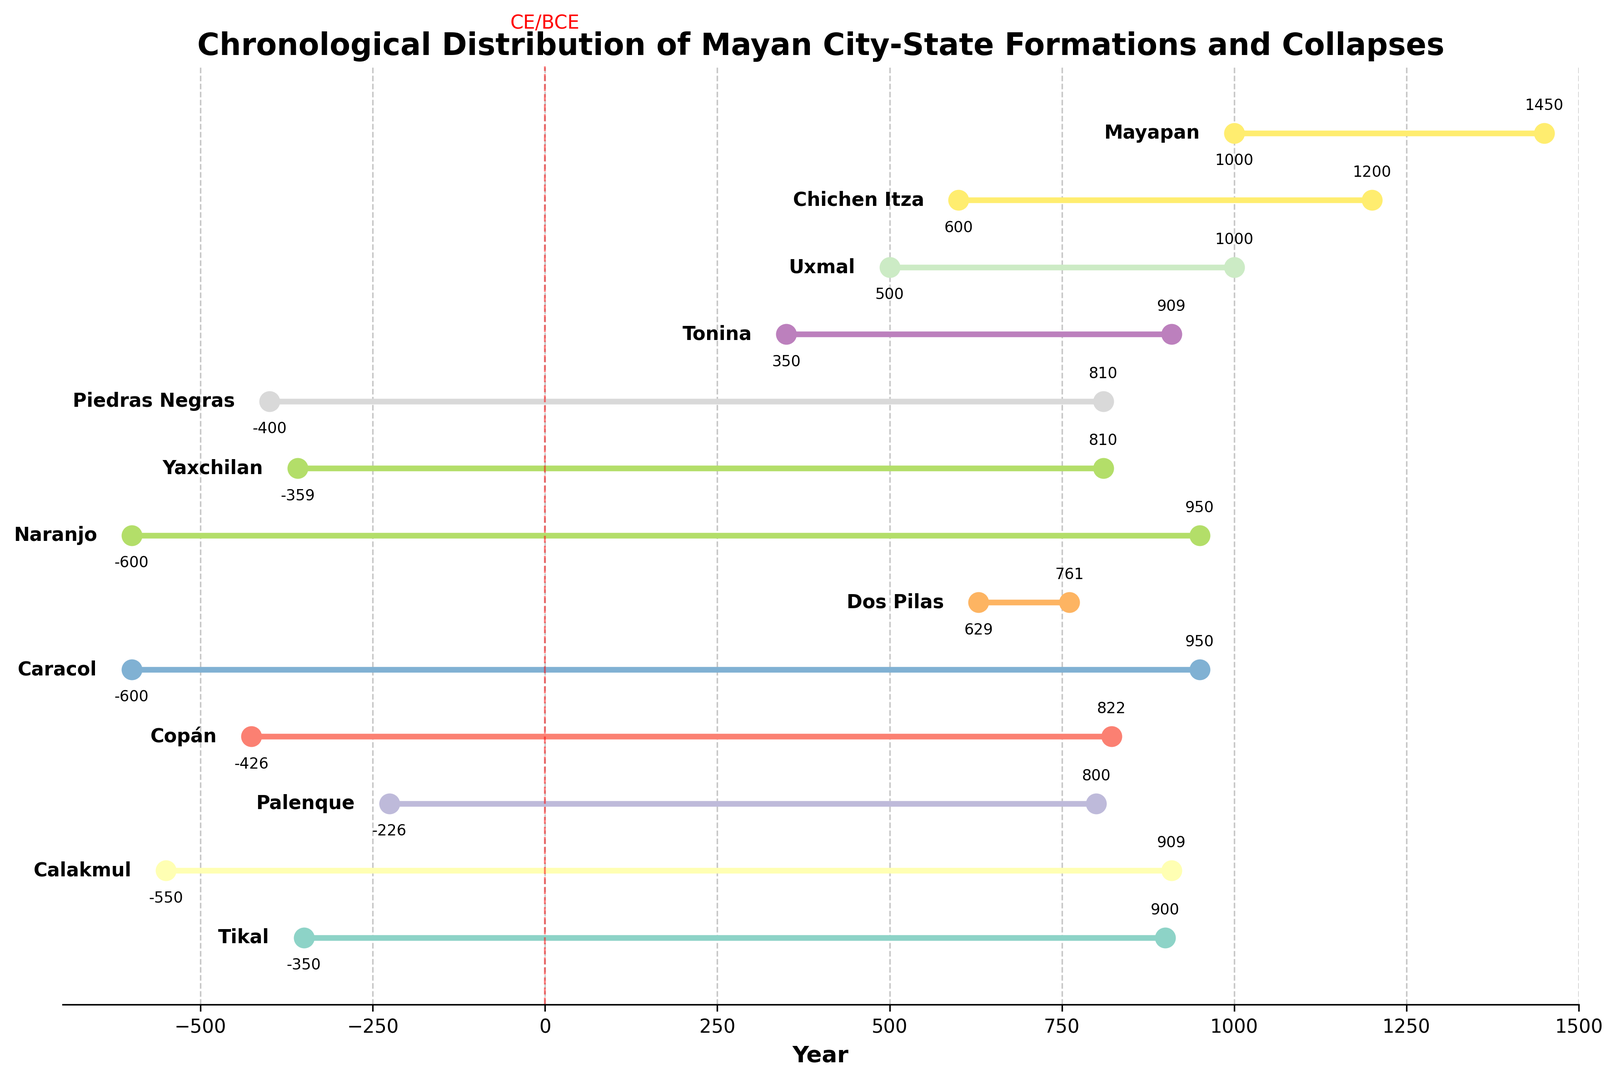Which Mayan city-state formed the earliest? To find the earliest formation, look at the lowest year value under 'Formation' events. The lowest value is -600 for Caracol and Naranjo.
Answer: Caracol and Naranjo Which Mayan city-state collapsed the latest? To find the latest collapse, look at the highest year value under 'Collapse' events. The highest value is 1450 for Mayapan.
Answer: Mayapan How many city-states were formed before the Common Era (BCE)? Identify the formation years that are negative (before CE). The city-states with negative formation years are: Tikal, Calakmul, Palenque, Copán, Caracol, Naranjo, Yaxchilan, and Piedras Negras, making a total of 8 city-states.
Answer: 8 How many years did Tikal exist? Find the difference between the collapse year and the formation year of Tikal. The collapse year is 900 and the formation year is -350. The total duration is 900 - (-350) = 1250 years.
Answer: 1250 years Which city-state had the shortest duration between its formation and collapse? Calculate the duration for each city-state by subtracting the formation year from the collapse year. Identify the smallest duration. Tonina was formed in 350 and collapsed in 909, which gives a duration of 909 - 350 = 559 years.
Answer: Tonina What is the average duration of existence for all Mayan city-states? Calculate the duration for each city-state and then find the average. Sum of durations: (1250 + 1459 + 1026 + 1248 + 1550 + 132 + 1550 + 1169 + 1210 + 559 + 500 + 600 + 450). The number of city-states is 13. Average = (15303 / 13) = Approximately 1177 years.
Answer: Approximately 1177 years Did any city-state formation events happen after the Common Era? Formation events after the CE have positive year values. Uxmal (500), Chichen Itza (600), Mayapan (1000), and Dos Pilas (629) are the city-states formed after CE.
Answer: Yes Which city-state formation and collapse events occur closest in the timeline? Examine the city-states' formation and collapse years to see which are closest. Dos Pilas formed in 629 and collapsed in 761, giving a difference of 132 years, which is the shortest.
Answer: Dos Pilas Did any city-states form and collapse at the same year? Check if there are any city-states with the same formation and collapse year. There are no such occurrences in the dataset.
Answer: No 